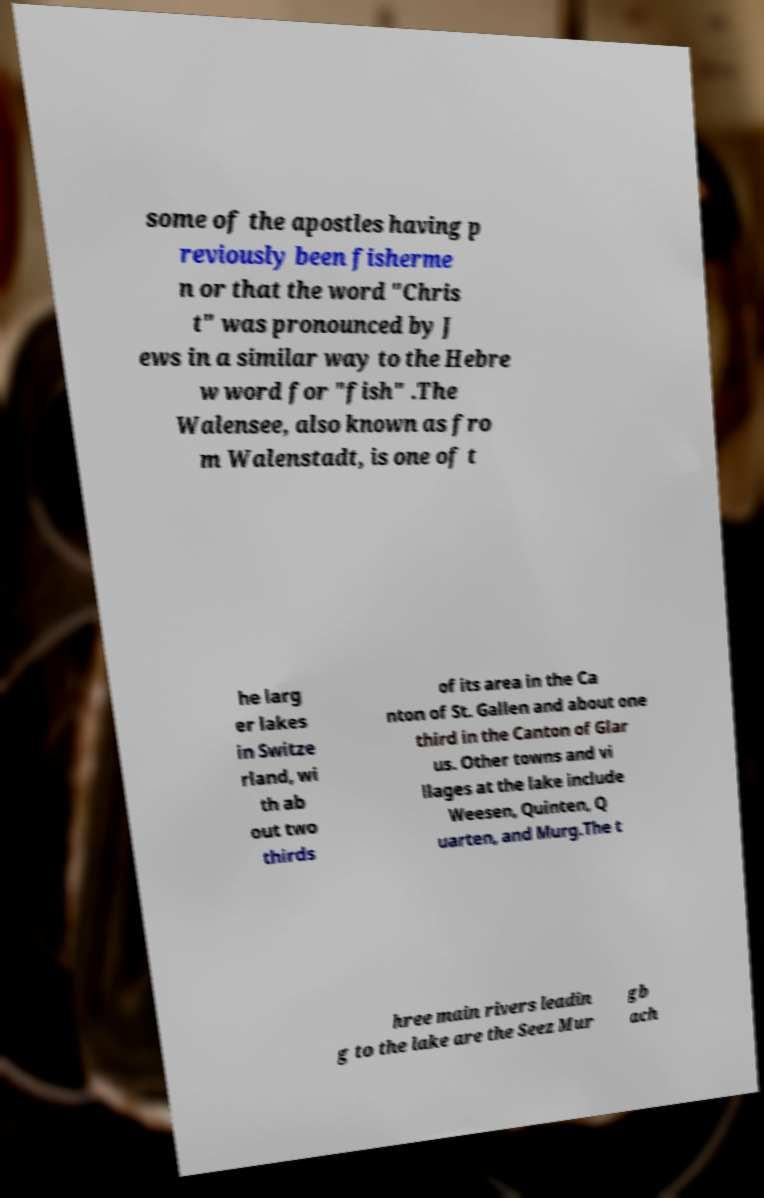Please read and relay the text visible in this image. What does it say? some of the apostles having p reviously been fisherme n or that the word "Chris t" was pronounced by J ews in a similar way to the Hebre w word for "fish" .The Walensee, also known as fro m Walenstadt, is one of t he larg er lakes in Switze rland, wi th ab out two thirds of its area in the Ca nton of St. Gallen and about one third in the Canton of Glar us. Other towns and vi llages at the lake include Weesen, Quinten, Q uarten, and Murg.The t hree main rivers leadin g to the lake are the Seez Mur gb ach 